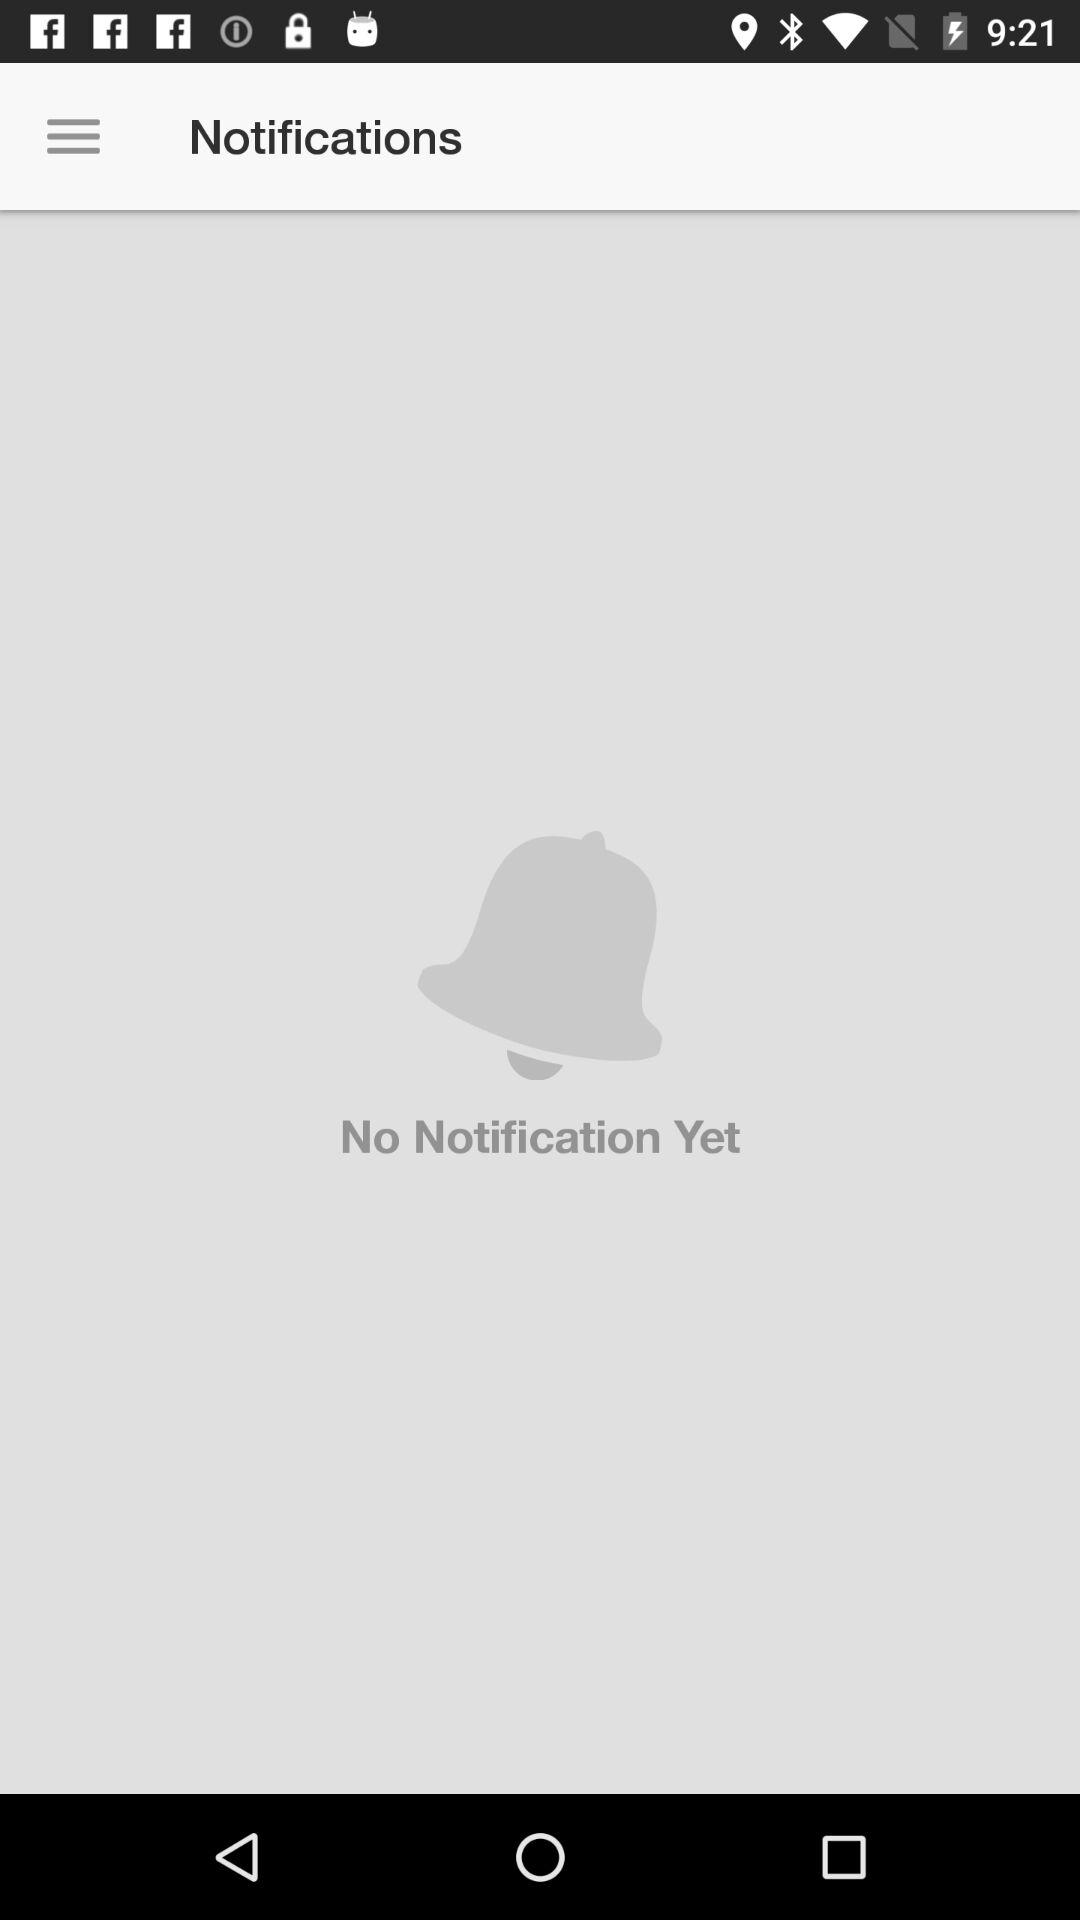How many notifications do I have?
Answer the question using a single word or phrase. 0 